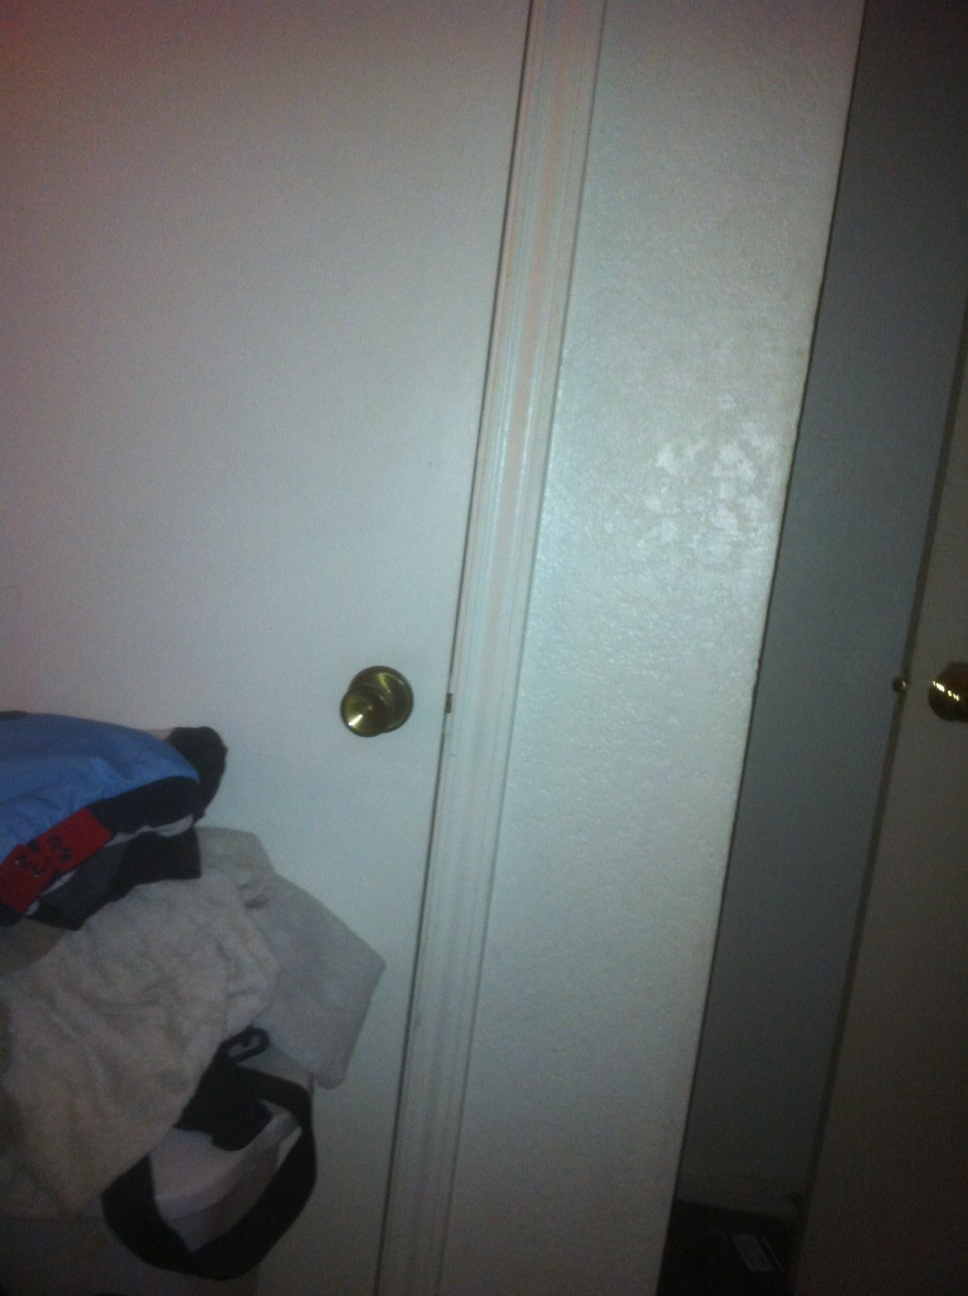Can you describe the door shown in the picture? Certainly! The door in the picture is white with a smooth finish and a standard gold-colored round doorknob on the right side. It appears to be slightly ajar, revealing a darker space behind it. There's also visible abrasion or discoloration along the door's right edge, suggesting wear or damage. What could be the possible reason for the wear on the door? The wear on the door could be from regular use where the door frequently rubs against some object or wall when opened or closed. It might also be from a specific incident that caused a scrape, or it could be due to the age of the door, where paint and material naturally degrade over time. 